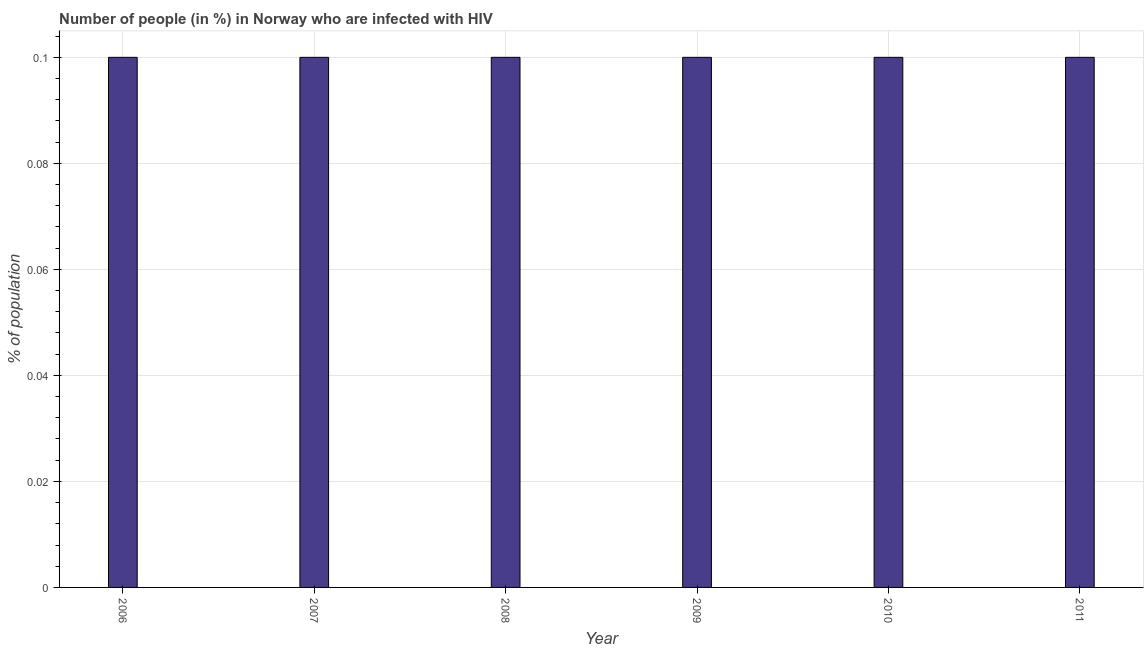Does the graph contain any zero values?
Ensure brevity in your answer.  No. What is the title of the graph?
Make the answer very short. Number of people (in %) in Norway who are infected with HIV. What is the label or title of the Y-axis?
Give a very brief answer. % of population. What is the number of people infected with hiv in 2009?
Offer a very short reply. 0.1. Across all years, what is the maximum number of people infected with hiv?
Keep it short and to the point. 0.1. Across all years, what is the minimum number of people infected with hiv?
Offer a terse response. 0.1. What is the sum of the number of people infected with hiv?
Your answer should be very brief. 0.6. What is the average number of people infected with hiv per year?
Your answer should be very brief. 0.1. Do a majority of the years between 2006 and 2007 (inclusive) have number of people infected with hiv greater than 0.1 %?
Your response must be concise. No. Is the difference between the number of people infected with hiv in 2007 and 2009 greater than the difference between any two years?
Your answer should be compact. Yes. What is the difference between the highest and the second highest number of people infected with hiv?
Your response must be concise. 0. Is the sum of the number of people infected with hiv in 2007 and 2009 greater than the maximum number of people infected with hiv across all years?
Give a very brief answer. Yes. What is the difference between the highest and the lowest number of people infected with hiv?
Make the answer very short. 0. Are all the bars in the graph horizontal?
Your answer should be very brief. No. What is the % of population of 2008?
Ensure brevity in your answer.  0.1. What is the % of population of 2009?
Your answer should be very brief. 0.1. What is the difference between the % of population in 2006 and 2007?
Your answer should be very brief. 0. What is the difference between the % of population in 2006 and 2008?
Your answer should be compact. 0. What is the difference between the % of population in 2007 and 2010?
Provide a succinct answer. 0. What is the difference between the % of population in 2008 and 2011?
Your answer should be very brief. 0. What is the difference between the % of population in 2010 and 2011?
Your answer should be compact. 0. What is the ratio of the % of population in 2006 to that in 2008?
Your answer should be very brief. 1. What is the ratio of the % of population in 2007 to that in 2008?
Provide a succinct answer. 1. What is the ratio of the % of population in 2007 to that in 2010?
Provide a short and direct response. 1. What is the ratio of the % of population in 2008 to that in 2009?
Keep it short and to the point. 1. What is the ratio of the % of population in 2008 to that in 2011?
Offer a terse response. 1. What is the ratio of the % of population in 2009 to that in 2010?
Your response must be concise. 1. What is the ratio of the % of population in 2009 to that in 2011?
Give a very brief answer. 1. 